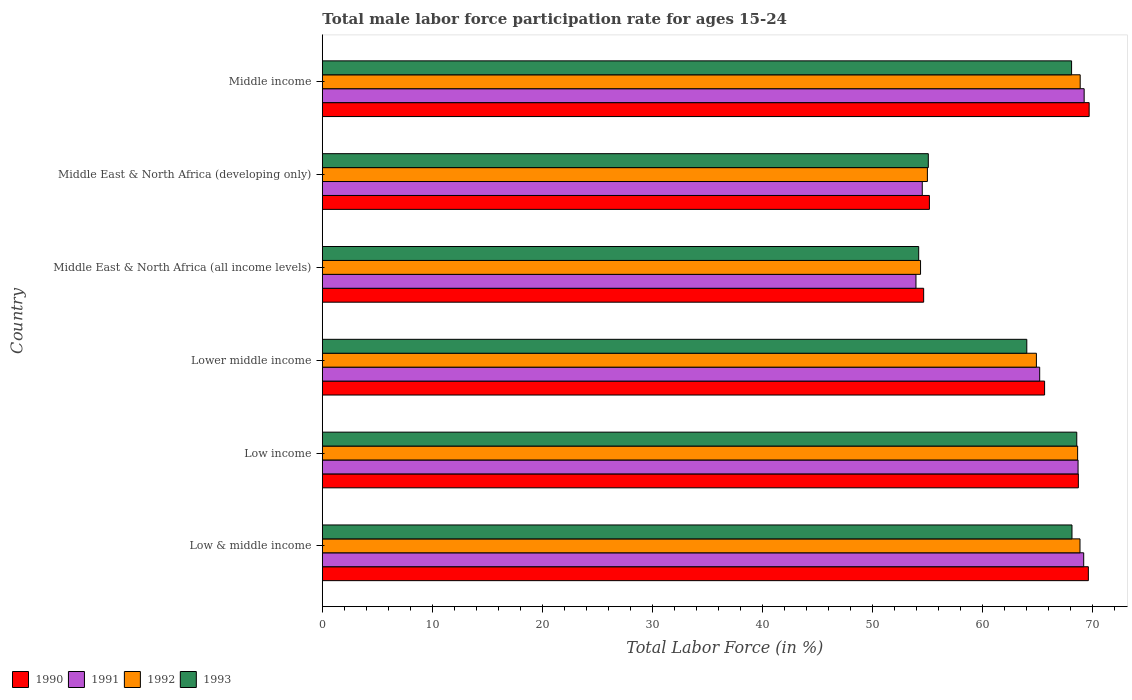How many different coloured bars are there?
Your response must be concise. 4. How many groups of bars are there?
Give a very brief answer. 6. Are the number of bars on each tick of the Y-axis equal?
Make the answer very short. Yes. How many bars are there on the 4th tick from the top?
Make the answer very short. 4. How many bars are there on the 3rd tick from the bottom?
Keep it short and to the point. 4. What is the label of the 4th group of bars from the top?
Give a very brief answer. Lower middle income. In how many cases, is the number of bars for a given country not equal to the number of legend labels?
Keep it short and to the point. 0. What is the male labor force participation rate in 1993 in Middle East & North Africa (all income levels)?
Give a very brief answer. 54.18. Across all countries, what is the maximum male labor force participation rate in 1990?
Offer a terse response. 69.67. Across all countries, what is the minimum male labor force participation rate in 1990?
Your answer should be compact. 54.63. In which country was the male labor force participation rate in 1993 maximum?
Make the answer very short. Low income. In which country was the male labor force participation rate in 1992 minimum?
Ensure brevity in your answer.  Middle East & North Africa (all income levels). What is the total male labor force participation rate in 1991 in the graph?
Keep it short and to the point. 380.65. What is the difference between the male labor force participation rate in 1990 in Low & middle income and that in Middle East & North Africa (developing only)?
Your answer should be very brief. 14.44. What is the difference between the male labor force participation rate in 1993 in Lower middle income and the male labor force participation rate in 1992 in Middle East & North Africa (all income levels)?
Provide a succinct answer. 9.65. What is the average male labor force participation rate in 1990 per country?
Offer a very short reply. 63.89. What is the difference between the male labor force participation rate in 1990 and male labor force participation rate in 1992 in Middle East & North Africa (all income levels)?
Make the answer very short. 0.28. In how many countries, is the male labor force participation rate in 1990 greater than 8 %?
Offer a very short reply. 6. What is the ratio of the male labor force participation rate in 1990 in Middle East & North Africa (developing only) to that in Middle income?
Your response must be concise. 0.79. Is the male labor force participation rate in 1990 in Low & middle income less than that in Middle East & North Africa (all income levels)?
Offer a very short reply. No. Is the difference between the male labor force participation rate in 1990 in Low income and Middle East & North Africa (developing only) greater than the difference between the male labor force participation rate in 1992 in Low income and Middle East & North Africa (developing only)?
Your answer should be compact. No. What is the difference between the highest and the second highest male labor force participation rate in 1990?
Keep it short and to the point. 0.07. What is the difference between the highest and the lowest male labor force participation rate in 1990?
Your answer should be very brief. 15.03. In how many countries, is the male labor force participation rate in 1993 greater than the average male labor force participation rate in 1993 taken over all countries?
Provide a succinct answer. 4. Is the sum of the male labor force participation rate in 1991 in Lower middle income and Middle East & North Africa (developing only) greater than the maximum male labor force participation rate in 1992 across all countries?
Offer a very short reply. Yes. Is it the case that in every country, the sum of the male labor force participation rate in 1993 and male labor force participation rate in 1990 is greater than the sum of male labor force participation rate in 1991 and male labor force participation rate in 1992?
Ensure brevity in your answer.  No. What does the 1st bar from the top in Low & middle income represents?
Ensure brevity in your answer.  1993. What is the difference between two consecutive major ticks on the X-axis?
Ensure brevity in your answer.  10. Where does the legend appear in the graph?
Your answer should be compact. Bottom left. How are the legend labels stacked?
Offer a terse response. Horizontal. What is the title of the graph?
Give a very brief answer. Total male labor force participation rate for ages 15-24. What is the label or title of the Y-axis?
Your answer should be very brief. Country. What is the Total Labor Force (in %) in 1990 in Low & middle income?
Give a very brief answer. 69.59. What is the Total Labor Force (in %) of 1991 in Low & middle income?
Ensure brevity in your answer.  69.17. What is the Total Labor Force (in %) in 1992 in Low & middle income?
Your answer should be very brief. 68.83. What is the Total Labor Force (in %) in 1993 in Low & middle income?
Offer a terse response. 68.11. What is the Total Labor Force (in %) of 1990 in Low income?
Provide a short and direct response. 68.69. What is the Total Labor Force (in %) of 1991 in Low income?
Your answer should be compact. 68.66. What is the Total Labor Force (in %) of 1992 in Low income?
Give a very brief answer. 68.62. What is the Total Labor Force (in %) of 1993 in Low income?
Ensure brevity in your answer.  68.54. What is the Total Labor Force (in %) of 1990 in Lower middle income?
Your answer should be very brief. 65.62. What is the Total Labor Force (in %) of 1991 in Lower middle income?
Your answer should be very brief. 65.17. What is the Total Labor Force (in %) in 1992 in Lower middle income?
Your answer should be very brief. 64.87. What is the Total Labor Force (in %) in 1993 in Lower middle income?
Keep it short and to the point. 64. What is the Total Labor Force (in %) in 1990 in Middle East & North Africa (all income levels)?
Offer a terse response. 54.63. What is the Total Labor Force (in %) in 1991 in Middle East & North Africa (all income levels)?
Provide a short and direct response. 53.93. What is the Total Labor Force (in %) of 1992 in Middle East & North Africa (all income levels)?
Ensure brevity in your answer.  54.35. What is the Total Labor Force (in %) in 1993 in Middle East & North Africa (all income levels)?
Your response must be concise. 54.18. What is the Total Labor Force (in %) in 1990 in Middle East & North Africa (developing only)?
Your response must be concise. 55.15. What is the Total Labor Force (in %) of 1991 in Middle East & North Africa (developing only)?
Your response must be concise. 54.5. What is the Total Labor Force (in %) in 1992 in Middle East & North Africa (developing only)?
Ensure brevity in your answer.  54.97. What is the Total Labor Force (in %) of 1993 in Middle East & North Africa (developing only)?
Provide a succinct answer. 55.05. What is the Total Labor Force (in %) in 1990 in Middle income?
Offer a terse response. 69.67. What is the Total Labor Force (in %) in 1991 in Middle income?
Keep it short and to the point. 69.21. What is the Total Labor Force (in %) of 1992 in Middle income?
Give a very brief answer. 68.85. What is the Total Labor Force (in %) of 1993 in Middle income?
Your response must be concise. 68.07. Across all countries, what is the maximum Total Labor Force (in %) in 1990?
Your answer should be very brief. 69.67. Across all countries, what is the maximum Total Labor Force (in %) of 1991?
Offer a terse response. 69.21. Across all countries, what is the maximum Total Labor Force (in %) of 1992?
Your answer should be compact. 68.85. Across all countries, what is the maximum Total Labor Force (in %) of 1993?
Your answer should be compact. 68.54. Across all countries, what is the minimum Total Labor Force (in %) of 1990?
Your response must be concise. 54.63. Across all countries, what is the minimum Total Labor Force (in %) in 1991?
Provide a succinct answer. 53.93. Across all countries, what is the minimum Total Labor Force (in %) in 1992?
Provide a succinct answer. 54.35. Across all countries, what is the minimum Total Labor Force (in %) of 1993?
Make the answer very short. 54.18. What is the total Total Labor Force (in %) in 1990 in the graph?
Your response must be concise. 383.35. What is the total Total Labor Force (in %) in 1991 in the graph?
Your answer should be compact. 380.65. What is the total Total Labor Force (in %) in 1992 in the graph?
Ensure brevity in your answer.  380.5. What is the total Total Labor Force (in %) in 1993 in the graph?
Your answer should be compact. 377.95. What is the difference between the Total Labor Force (in %) in 1990 in Low & middle income and that in Low income?
Offer a very short reply. 0.91. What is the difference between the Total Labor Force (in %) of 1991 in Low & middle income and that in Low income?
Provide a succinct answer. 0.51. What is the difference between the Total Labor Force (in %) in 1992 in Low & middle income and that in Low income?
Your response must be concise. 0.22. What is the difference between the Total Labor Force (in %) in 1993 in Low & middle income and that in Low income?
Offer a very short reply. -0.43. What is the difference between the Total Labor Force (in %) of 1990 in Low & middle income and that in Lower middle income?
Offer a very short reply. 3.98. What is the difference between the Total Labor Force (in %) of 1991 in Low & middle income and that in Lower middle income?
Ensure brevity in your answer.  4. What is the difference between the Total Labor Force (in %) of 1992 in Low & middle income and that in Lower middle income?
Ensure brevity in your answer.  3.96. What is the difference between the Total Labor Force (in %) in 1993 in Low & middle income and that in Lower middle income?
Give a very brief answer. 4.11. What is the difference between the Total Labor Force (in %) in 1990 in Low & middle income and that in Middle East & North Africa (all income levels)?
Offer a terse response. 14.96. What is the difference between the Total Labor Force (in %) of 1991 in Low & middle income and that in Middle East & North Africa (all income levels)?
Provide a succinct answer. 15.24. What is the difference between the Total Labor Force (in %) in 1992 in Low & middle income and that in Middle East & North Africa (all income levels)?
Ensure brevity in your answer.  14.49. What is the difference between the Total Labor Force (in %) of 1993 in Low & middle income and that in Middle East & North Africa (all income levels)?
Give a very brief answer. 13.93. What is the difference between the Total Labor Force (in %) of 1990 in Low & middle income and that in Middle East & North Africa (developing only)?
Your answer should be compact. 14.44. What is the difference between the Total Labor Force (in %) of 1991 in Low & middle income and that in Middle East & North Africa (developing only)?
Provide a short and direct response. 14.67. What is the difference between the Total Labor Force (in %) of 1992 in Low & middle income and that in Middle East & North Africa (developing only)?
Offer a terse response. 13.86. What is the difference between the Total Labor Force (in %) in 1993 in Low & middle income and that in Middle East & North Africa (developing only)?
Your response must be concise. 13.05. What is the difference between the Total Labor Force (in %) in 1990 in Low & middle income and that in Middle income?
Offer a very short reply. -0.07. What is the difference between the Total Labor Force (in %) of 1991 in Low & middle income and that in Middle income?
Offer a terse response. -0.04. What is the difference between the Total Labor Force (in %) of 1992 in Low & middle income and that in Middle income?
Give a very brief answer. -0.02. What is the difference between the Total Labor Force (in %) of 1993 in Low & middle income and that in Middle income?
Provide a succinct answer. 0.04. What is the difference between the Total Labor Force (in %) of 1990 in Low income and that in Lower middle income?
Your answer should be very brief. 3.07. What is the difference between the Total Labor Force (in %) in 1991 in Low income and that in Lower middle income?
Make the answer very short. 3.49. What is the difference between the Total Labor Force (in %) of 1992 in Low income and that in Lower middle income?
Provide a short and direct response. 3.74. What is the difference between the Total Labor Force (in %) in 1993 in Low income and that in Lower middle income?
Your response must be concise. 4.54. What is the difference between the Total Labor Force (in %) of 1990 in Low income and that in Middle East & North Africa (all income levels)?
Offer a terse response. 14.05. What is the difference between the Total Labor Force (in %) in 1991 in Low income and that in Middle East & North Africa (all income levels)?
Keep it short and to the point. 14.73. What is the difference between the Total Labor Force (in %) in 1992 in Low income and that in Middle East & North Africa (all income levels)?
Your answer should be very brief. 14.27. What is the difference between the Total Labor Force (in %) in 1993 in Low income and that in Middle East & North Africa (all income levels)?
Provide a succinct answer. 14.36. What is the difference between the Total Labor Force (in %) of 1990 in Low income and that in Middle East & North Africa (developing only)?
Offer a terse response. 13.53. What is the difference between the Total Labor Force (in %) in 1991 in Low income and that in Middle East & North Africa (developing only)?
Keep it short and to the point. 14.15. What is the difference between the Total Labor Force (in %) in 1992 in Low income and that in Middle East & North Africa (developing only)?
Offer a very short reply. 13.65. What is the difference between the Total Labor Force (in %) in 1993 in Low income and that in Middle East & North Africa (developing only)?
Your answer should be very brief. 13.49. What is the difference between the Total Labor Force (in %) in 1990 in Low income and that in Middle income?
Ensure brevity in your answer.  -0.98. What is the difference between the Total Labor Force (in %) in 1991 in Low income and that in Middle income?
Provide a succinct answer. -0.55. What is the difference between the Total Labor Force (in %) in 1992 in Low income and that in Middle income?
Ensure brevity in your answer.  -0.23. What is the difference between the Total Labor Force (in %) in 1993 in Low income and that in Middle income?
Keep it short and to the point. 0.47. What is the difference between the Total Labor Force (in %) in 1990 in Lower middle income and that in Middle East & North Africa (all income levels)?
Ensure brevity in your answer.  10.99. What is the difference between the Total Labor Force (in %) in 1991 in Lower middle income and that in Middle East & North Africa (all income levels)?
Your answer should be compact. 11.24. What is the difference between the Total Labor Force (in %) of 1992 in Lower middle income and that in Middle East & North Africa (all income levels)?
Provide a short and direct response. 10.53. What is the difference between the Total Labor Force (in %) of 1993 in Lower middle income and that in Middle East & North Africa (all income levels)?
Offer a terse response. 9.82. What is the difference between the Total Labor Force (in %) in 1990 in Lower middle income and that in Middle East & North Africa (developing only)?
Give a very brief answer. 10.46. What is the difference between the Total Labor Force (in %) in 1991 in Lower middle income and that in Middle East & North Africa (developing only)?
Provide a succinct answer. 10.67. What is the difference between the Total Labor Force (in %) in 1992 in Lower middle income and that in Middle East & North Africa (developing only)?
Your answer should be compact. 9.91. What is the difference between the Total Labor Force (in %) in 1993 in Lower middle income and that in Middle East & North Africa (developing only)?
Provide a succinct answer. 8.95. What is the difference between the Total Labor Force (in %) in 1990 in Lower middle income and that in Middle income?
Provide a short and direct response. -4.05. What is the difference between the Total Labor Force (in %) of 1991 in Lower middle income and that in Middle income?
Offer a terse response. -4.04. What is the difference between the Total Labor Force (in %) in 1992 in Lower middle income and that in Middle income?
Provide a short and direct response. -3.98. What is the difference between the Total Labor Force (in %) in 1993 in Lower middle income and that in Middle income?
Provide a short and direct response. -4.07. What is the difference between the Total Labor Force (in %) of 1990 in Middle East & North Africa (all income levels) and that in Middle East & North Africa (developing only)?
Keep it short and to the point. -0.52. What is the difference between the Total Labor Force (in %) of 1991 in Middle East & North Africa (all income levels) and that in Middle East & North Africa (developing only)?
Ensure brevity in your answer.  -0.57. What is the difference between the Total Labor Force (in %) in 1992 in Middle East & North Africa (all income levels) and that in Middle East & North Africa (developing only)?
Offer a terse response. -0.62. What is the difference between the Total Labor Force (in %) of 1993 in Middle East & North Africa (all income levels) and that in Middle East & North Africa (developing only)?
Provide a short and direct response. -0.88. What is the difference between the Total Labor Force (in %) of 1990 in Middle East & North Africa (all income levels) and that in Middle income?
Provide a succinct answer. -15.03. What is the difference between the Total Labor Force (in %) in 1991 in Middle East & North Africa (all income levels) and that in Middle income?
Your response must be concise. -15.28. What is the difference between the Total Labor Force (in %) in 1992 in Middle East & North Africa (all income levels) and that in Middle income?
Your response must be concise. -14.5. What is the difference between the Total Labor Force (in %) of 1993 in Middle East & North Africa (all income levels) and that in Middle income?
Your answer should be very brief. -13.89. What is the difference between the Total Labor Force (in %) in 1990 in Middle East & North Africa (developing only) and that in Middle income?
Offer a terse response. -14.51. What is the difference between the Total Labor Force (in %) of 1991 in Middle East & North Africa (developing only) and that in Middle income?
Ensure brevity in your answer.  -14.71. What is the difference between the Total Labor Force (in %) in 1992 in Middle East & North Africa (developing only) and that in Middle income?
Keep it short and to the point. -13.88. What is the difference between the Total Labor Force (in %) in 1993 in Middle East & North Africa (developing only) and that in Middle income?
Your answer should be compact. -13.02. What is the difference between the Total Labor Force (in %) in 1990 in Low & middle income and the Total Labor Force (in %) in 1991 in Low income?
Ensure brevity in your answer.  0.94. What is the difference between the Total Labor Force (in %) in 1990 in Low & middle income and the Total Labor Force (in %) in 1992 in Low income?
Provide a succinct answer. 0.98. What is the difference between the Total Labor Force (in %) of 1990 in Low & middle income and the Total Labor Force (in %) of 1993 in Low income?
Make the answer very short. 1.05. What is the difference between the Total Labor Force (in %) in 1991 in Low & middle income and the Total Labor Force (in %) in 1992 in Low income?
Provide a short and direct response. 0.55. What is the difference between the Total Labor Force (in %) in 1991 in Low & middle income and the Total Labor Force (in %) in 1993 in Low income?
Offer a very short reply. 0.63. What is the difference between the Total Labor Force (in %) of 1992 in Low & middle income and the Total Labor Force (in %) of 1993 in Low income?
Give a very brief answer. 0.29. What is the difference between the Total Labor Force (in %) in 1990 in Low & middle income and the Total Labor Force (in %) in 1991 in Lower middle income?
Keep it short and to the point. 4.42. What is the difference between the Total Labor Force (in %) in 1990 in Low & middle income and the Total Labor Force (in %) in 1992 in Lower middle income?
Provide a succinct answer. 4.72. What is the difference between the Total Labor Force (in %) in 1990 in Low & middle income and the Total Labor Force (in %) in 1993 in Lower middle income?
Ensure brevity in your answer.  5.59. What is the difference between the Total Labor Force (in %) of 1991 in Low & middle income and the Total Labor Force (in %) of 1992 in Lower middle income?
Ensure brevity in your answer.  4.3. What is the difference between the Total Labor Force (in %) in 1991 in Low & middle income and the Total Labor Force (in %) in 1993 in Lower middle income?
Keep it short and to the point. 5.17. What is the difference between the Total Labor Force (in %) of 1992 in Low & middle income and the Total Labor Force (in %) of 1993 in Lower middle income?
Offer a very short reply. 4.83. What is the difference between the Total Labor Force (in %) of 1990 in Low & middle income and the Total Labor Force (in %) of 1991 in Middle East & North Africa (all income levels)?
Your response must be concise. 15.66. What is the difference between the Total Labor Force (in %) in 1990 in Low & middle income and the Total Labor Force (in %) in 1992 in Middle East & North Africa (all income levels)?
Your response must be concise. 15.25. What is the difference between the Total Labor Force (in %) of 1990 in Low & middle income and the Total Labor Force (in %) of 1993 in Middle East & North Africa (all income levels)?
Your answer should be compact. 15.42. What is the difference between the Total Labor Force (in %) of 1991 in Low & middle income and the Total Labor Force (in %) of 1992 in Middle East & North Africa (all income levels)?
Give a very brief answer. 14.82. What is the difference between the Total Labor Force (in %) in 1991 in Low & middle income and the Total Labor Force (in %) in 1993 in Middle East & North Africa (all income levels)?
Offer a very short reply. 14.99. What is the difference between the Total Labor Force (in %) in 1992 in Low & middle income and the Total Labor Force (in %) in 1993 in Middle East & North Africa (all income levels)?
Keep it short and to the point. 14.66. What is the difference between the Total Labor Force (in %) in 1990 in Low & middle income and the Total Labor Force (in %) in 1991 in Middle East & North Africa (developing only)?
Keep it short and to the point. 15.09. What is the difference between the Total Labor Force (in %) of 1990 in Low & middle income and the Total Labor Force (in %) of 1992 in Middle East & North Africa (developing only)?
Your answer should be compact. 14.62. What is the difference between the Total Labor Force (in %) of 1990 in Low & middle income and the Total Labor Force (in %) of 1993 in Middle East & North Africa (developing only)?
Give a very brief answer. 14.54. What is the difference between the Total Labor Force (in %) in 1991 in Low & middle income and the Total Labor Force (in %) in 1992 in Middle East & North Africa (developing only)?
Make the answer very short. 14.2. What is the difference between the Total Labor Force (in %) of 1991 in Low & middle income and the Total Labor Force (in %) of 1993 in Middle East & North Africa (developing only)?
Your answer should be very brief. 14.12. What is the difference between the Total Labor Force (in %) of 1992 in Low & middle income and the Total Labor Force (in %) of 1993 in Middle East & North Africa (developing only)?
Your answer should be very brief. 13.78. What is the difference between the Total Labor Force (in %) in 1990 in Low & middle income and the Total Labor Force (in %) in 1991 in Middle income?
Keep it short and to the point. 0.38. What is the difference between the Total Labor Force (in %) of 1990 in Low & middle income and the Total Labor Force (in %) of 1992 in Middle income?
Keep it short and to the point. 0.74. What is the difference between the Total Labor Force (in %) of 1990 in Low & middle income and the Total Labor Force (in %) of 1993 in Middle income?
Your answer should be compact. 1.52. What is the difference between the Total Labor Force (in %) of 1991 in Low & middle income and the Total Labor Force (in %) of 1992 in Middle income?
Offer a terse response. 0.32. What is the difference between the Total Labor Force (in %) in 1991 in Low & middle income and the Total Labor Force (in %) in 1993 in Middle income?
Your answer should be compact. 1.1. What is the difference between the Total Labor Force (in %) of 1992 in Low & middle income and the Total Labor Force (in %) of 1993 in Middle income?
Make the answer very short. 0.76. What is the difference between the Total Labor Force (in %) in 1990 in Low income and the Total Labor Force (in %) in 1991 in Lower middle income?
Your answer should be compact. 3.51. What is the difference between the Total Labor Force (in %) of 1990 in Low income and the Total Labor Force (in %) of 1992 in Lower middle income?
Offer a terse response. 3.81. What is the difference between the Total Labor Force (in %) of 1990 in Low income and the Total Labor Force (in %) of 1993 in Lower middle income?
Your answer should be very brief. 4.68. What is the difference between the Total Labor Force (in %) in 1991 in Low income and the Total Labor Force (in %) in 1992 in Lower middle income?
Your answer should be very brief. 3.78. What is the difference between the Total Labor Force (in %) in 1991 in Low income and the Total Labor Force (in %) in 1993 in Lower middle income?
Ensure brevity in your answer.  4.66. What is the difference between the Total Labor Force (in %) in 1992 in Low income and the Total Labor Force (in %) in 1993 in Lower middle income?
Provide a short and direct response. 4.62. What is the difference between the Total Labor Force (in %) in 1990 in Low income and the Total Labor Force (in %) in 1991 in Middle East & North Africa (all income levels)?
Provide a short and direct response. 14.75. What is the difference between the Total Labor Force (in %) in 1990 in Low income and the Total Labor Force (in %) in 1992 in Middle East & North Africa (all income levels)?
Offer a very short reply. 14.34. What is the difference between the Total Labor Force (in %) of 1990 in Low income and the Total Labor Force (in %) of 1993 in Middle East & North Africa (all income levels)?
Your answer should be very brief. 14.51. What is the difference between the Total Labor Force (in %) in 1991 in Low income and the Total Labor Force (in %) in 1992 in Middle East & North Africa (all income levels)?
Give a very brief answer. 14.31. What is the difference between the Total Labor Force (in %) of 1991 in Low income and the Total Labor Force (in %) of 1993 in Middle East & North Africa (all income levels)?
Provide a short and direct response. 14.48. What is the difference between the Total Labor Force (in %) in 1992 in Low income and the Total Labor Force (in %) in 1993 in Middle East & North Africa (all income levels)?
Provide a succinct answer. 14.44. What is the difference between the Total Labor Force (in %) in 1990 in Low income and the Total Labor Force (in %) in 1991 in Middle East & North Africa (developing only)?
Your answer should be compact. 14.18. What is the difference between the Total Labor Force (in %) of 1990 in Low income and the Total Labor Force (in %) of 1992 in Middle East & North Africa (developing only)?
Offer a terse response. 13.72. What is the difference between the Total Labor Force (in %) in 1990 in Low income and the Total Labor Force (in %) in 1993 in Middle East & North Africa (developing only)?
Make the answer very short. 13.63. What is the difference between the Total Labor Force (in %) in 1991 in Low income and the Total Labor Force (in %) in 1992 in Middle East & North Africa (developing only)?
Provide a short and direct response. 13.69. What is the difference between the Total Labor Force (in %) of 1991 in Low income and the Total Labor Force (in %) of 1993 in Middle East & North Africa (developing only)?
Provide a short and direct response. 13.6. What is the difference between the Total Labor Force (in %) of 1992 in Low income and the Total Labor Force (in %) of 1993 in Middle East & North Africa (developing only)?
Your answer should be compact. 13.56. What is the difference between the Total Labor Force (in %) of 1990 in Low income and the Total Labor Force (in %) of 1991 in Middle income?
Your answer should be compact. -0.53. What is the difference between the Total Labor Force (in %) in 1990 in Low income and the Total Labor Force (in %) in 1992 in Middle income?
Ensure brevity in your answer.  -0.17. What is the difference between the Total Labor Force (in %) in 1990 in Low income and the Total Labor Force (in %) in 1993 in Middle income?
Provide a succinct answer. 0.62. What is the difference between the Total Labor Force (in %) of 1991 in Low income and the Total Labor Force (in %) of 1992 in Middle income?
Make the answer very short. -0.19. What is the difference between the Total Labor Force (in %) of 1991 in Low income and the Total Labor Force (in %) of 1993 in Middle income?
Offer a terse response. 0.59. What is the difference between the Total Labor Force (in %) in 1992 in Low income and the Total Labor Force (in %) in 1993 in Middle income?
Give a very brief answer. 0.55. What is the difference between the Total Labor Force (in %) of 1990 in Lower middle income and the Total Labor Force (in %) of 1991 in Middle East & North Africa (all income levels)?
Keep it short and to the point. 11.68. What is the difference between the Total Labor Force (in %) of 1990 in Lower middle income and the Total Labor Force (in %) of 1992 in Middle East & North Africa (all income levels)?
Your response must be concise. 11.27. What is the difference between the Total Labor Force (in %) of 1990 in Lower middle income and the Total Labor Force (in %) of 1993 in Middle East & North Africa (all income levels)?
Provide a short and direct response. 11.44. What is the difference between the Total Labor Force (in %) in 1991 in Lower middle income and the Total Labor Force (in %) in 1992 in Middle East & North Africa (all income levels)?
Keep it short and to the point. 10.82. What is the difference between the Total Labor Force (in %) in 1991 in Lower middle income and the Total Labor Force (in %) in 1993 in Middle East & North Africa (all income levels)?
Your answer should be very brief. 10.99. What is the difference between the Total Labor Force (in %) of 1992 in Lower middle income and the Total Labor Force (in %) of 1993 in Middle East & North Africa (all income levels)?
Offer a terse response. 10.7. What is the difference between the Total Labor Force (in %) of 1990 in Lower middle income and the Total Labor Force (in %) of 1991 in Middle East & North Africa (developing only)?
Make the answer very short. 11.11. What is the difference between the Total Labor Force (in %) of 1990 in Lower middle income and the Total Labor Force (in %) of 1992 in Middle East & North Africa (developing only)?
Your response must be concise. 10.65. What is the difference between the Total Labor Force (in %) in 1990 in Lower middle income and the Total Labor Force (in %) in 1993 in Middle East & North Africa (developing only)?
Keep it short and to the point. 10.56. What is the difference between the Total Labor Force (in %) of 1991 in Lower middle income and the Total Labor Force (in %) of 1992 in Middle East & North Africa (developing only)?
Give a very brief answer. 10.2. What is the difference between the Total Labor Force (in %) in 1991 in Lower middle income and the Total Labor Force (in %) in 1993 in Middle East & North Africa (developing only)?
Your answer should be very brief. 10.12. What is the difference between the Total Labor Force (in %) of 1992 in Lower middle income and the Total Labor Force (in %) of 1993 in Middle East & North Africa (developing only)?
Provide a succinct answer. 9.82. What is the difference between the Total Labor Force (in %) of 1990 in Lower middle income and the Total Labor Force (in %) of 1991 in Middle income?
Provide a succinct answer. -3.59. What is the difference between the Total Labor Force (in %) of 1990 in Lower middle income and the Total Labor Force (in %) of 1992 in Middle income?
Give a very brief answer. -3.23. What is the difference between the Total Labor Force (in %) of 1990 in Lower middle income and the Total Labor Force (in %) of 1993 in Middle income?
Ensure brevity in your answer.  -2.45. What is the difference between the Total Labor Force (in %) of 1991 in Lower middle income and the Total Labor Force (in %) of 1992 in Middle income?
Ensure brevity in your answer.  -3.68. What is the difference between the Total Labor Force (in %) in 1991 in Lower middle income and the Total Labor Force (in %) in 1993 in Middle income?
Offer a terse response. -2.9. What is the difference between the Total Labor Force (in %) in 1992 in Lower middle income and the Total Labor Force (in %) in 1993 in Middle income?
Provide a short and direct response. -3.2. What is the difference between the Total Labor Force (in %) in 1990 in Middle East & North Africa (all income levels) and the Total Labor Force (in %) in 1991 in Middle East & North Africa (developing only)?
Provide a succinct answer. 0.13. What is the difference between the Total Labor Force (in %) of 1990 in Middle East & North Africa (all income levels) and the Total Labor Force (in %) of 1992 in Middle East & North Africa (developing only)?
Your response must be concise. -0.34. What is the difference between the Total Labor Force (in %) of 1990 in Middle East & North Africa (all income levels) and the Total Labor Force (in %) of 1993 in Middle East & North Africa (developing only)?
Your response must be concise. -0.42. What is the difference between the Total Labor Force (in %) of 1991 in Middle East & North Africa (all income levels) and the Total Labor Force (in %) of 1992 in Middle East & North Africa (developing only)?
Provide a short and direct response. -1.04. What is the difference between the Total Labor Force (in %) of 1991 in Middle East & North Africa (all income levels) and the Total Labor Force (in %) of 1993 in Middle East & North Africa (developing only)?
Give a very brief answer. -1.12. What is the difference between the Total Labor Force (in %) in 1992 in Middle East & North Africa (all income levels) and the Total Labor Force (in %) in 1993 in Middle East & North Africa (developing only)?
Ensure brevity in your answer.  -0.7. What is the difference between the Total Labor Force (in %) of 1990 in Middle East & North Africa (all income levels) and the Total Labor Force (in %) of 1991 in Middle income?
Make the answer very short. -14.58. What is the difference between the Total Labor Force (in %) of 1990 in Middle East & North Africa (all income levels) and the Total Labor Force (in %) of 1992 in Middle income?
Offer a terse response. -14.22. What is the difference between the Total Labor Force (in %) in 1990 in Middle East & North Africa (all income levels) and the Total Labor Force (in %) in 1993 in Middle income?
Provide a succinct answer. -13.44. What is the difference between the Total Labor Force (in %) in 1991 in Middle East & North Africa (all income levels) and the Total Labor Force (in %) in 1992 in Middle income?
Ensure brevity in your answer.  -14.92. What is the difference between the Total Labor Force (in %) of 1991 in Middle East & North Africa (all income levels) and the Total Labor Force (in %) of 1993 in Middle income?
Make the answer very short. -14.14. What is the difference between the Total Labor Force (in %) of 1992 in Middle East & North Africa (all income levels) and the Total Labor Force (in %) of 1993 in Middle income?
Ensure brevity in your answer.  -13.72. What is the difference between the Total Labor Force (in %) of 1990 in Middle East & North Africa (developing only) and the Total Labor Force (in %) of 1991 in Middle income?
Your answer should be compact. -14.06. What is the difference between the Total Labor Force (in %) of 1990 in Middle East & North Africa (developing only) and the Total Labor Force (in %) of 1992 in Middle income?
Offer a very short reply. -13.7. What is the difference between the Total Labor Force (in %) in 1990 in Middle East & North Africa (developing only) and the Total Labor Force (in %) in 1993 in Middle income?
Make the answer very short. -12.92. What is the difference between the Total Labor Force (in %) in 1991 in Middle East & North Africa (developing only) and the Total Labor Force (in %) in 1992 in Middle income?
Your answer should be very brief. -14.35. What is the difference between the Total Labor Force (in %) in 1991 in Middle East & North Africa (developing only) and the Total Labor Force (in %) in 1993 in Middle income?
Your answer should be compact. -13.57. What is the difference between the Total Labor Force (in %) in 1992 in Middle East & North Africa (developing only) and the Total Labor Force (in %) in 1993 in Middle income?
Provide a short and direct response. -13.1. What is the average Total Labor Force (in %) in 1990 per country?
Keep it short and to the point. 63.89. What is the average Total Labor Force (in %) of 1991 per country?
Make the answer very short. 63.44. What is the average Total Labor Force (in %) of 1992 per country?
Provide a succinct answer. 63.42. What is the average Total Labor Force (in %) in 1993 per country?
Give a very brief answer. 62.99. What is the difference between the Total Labor Force (in %) of 1990 and Total Labor Force (in %) of 1991 in Low & middle income?
Offer a very short reply. 0.42. What is the difference between the Total Labor Force (in %) of 1990 and Total Labor Force (in %) of 1992 in Low & middle income?
Your response must be concise. 0.76. What is the difference between the Total Labor Force (in %) in 1990 and Total Labor Force (in %) in 1993 in Low & middle income?
Your answer should be compact. 1.49. What is the difference between the Total Labor Force (in %) of 1991 and Total Labor Force (in %) of 1992 in Low & middle income?
Keep it short and to the point. 0.34. What is the difference between the Total Labor Force (in %) of 1991 and Total Labor Force (in %) of 1993 in Low & middle income?
Ensure brevity in your answer.  1.06. What is the difference between the Total Labor Force (in %) of 1992 and Total Labor Force (in %) of 1993 in Low & middle income?
Your response must be concise. 0.73. What is the difference between the Total Labor Force (in %) of 1990 and Total Labor Force (in %) of 1991 in Low income?
Give a very brief answer. 0.03. What is the difference between the Total Labor Force (in %) of 1990 and Total Labor Force (in %) of 1992 in Low income?
Offer a terse response. 0.07. What is the difference between the Total Labor Force (in %) of 1990 and Total Labor Force (in %) of 1993 in Low income?
Your answer should be compact. 0.14. What is the difference between the Total Labor Force (in %) of 1991 and Total Labor Force (in %) of 1992 in Low income?
Make the answer very short. 0.04. What is the difference between the Total Labor Force (in %) of 1991 and Total Labor Force (in %) of 1993 in Low income?
Offer a very short reply. 0.12. What is the difference between the Total Labor Force (in %) in 1992 and Total Labor Force (in %) in 1993 in Low income?
Offer a very short reply. 0.08. What is the difference between the Total Labor Force (in %) in 1990 and Total Labor Force (in %) in 1991 in Lower middle income?
Your response must be concise. 0.45. What is the difference between the Total Labor Force (in %) in 1990 and Total Labor Force (in %) in 1992 in Lower middle income?
Your response must be concise. 0.74. What is the difference between the Total Labor Force (in %) of 1990 and Total Labor Force (in %) of 1993 in Lower middle income?
Your response must be concise. 1.62. What is the difference between the Total Labor Force (in %) in 1991 and Total Labor Force (in %) in 1992 in Lower middle income?
Provide a short and direct response. 0.3. What is the difference between the Total Labor Force (in %) in 1991 and Total Labor Force (in %) in 1993 in Lower middle income?
Offer a very short reply. 1.17. What is the difference between the Total Labor Force (in %) in 1992 and Total Labor Force (in %) in 1993 in Lower middle income?
Provide a succinct answer. 0.87. What is the difference between the Total Labor Force (in %) of 1990 and Total Labor Force (in %) of 1991 in Middle East & North Africa (all income levels)?
Provide a succinct answer. 0.7. What is the difference between the Total Labor Force (in %) of 1990 and Total Labor Force (in %) of 1992 in Middle East & North Africa (all income levels)?
Your answer should be compact. 0.28. What is the difference between the Total Labor Force (in %) in 1990 and Total Labor Force (in %) in 1993 in Middle East & North Africa (all income levels)?
Your answer should be compact. 0.45. What is the difference between the Total Labor Force (in %) of 1991 and Total Labor Force (in %) of 1992 in Middle East & North Africa (all income levels)?
Provide a succinct answer. -0.42. What is the difference between the Total Labor Force (in %) in 1991 and Total Labor Force (in %) in 1993 in Middle East & North Africa (all income levels)?
Provide a succinct answer. -0.25. What is the difference between the Total Labor Force (in %) in 1992 and Total Labor Force (in %) in 1993 in Middle East & North Africa (all income levels)?
Ensure brevity in your answer.  0.17. What is the difference between the Total Labor Force (in %) in 1990 and Total Labor Force (in %) in 1991 in Middle East & North Africa (developing only)?
Provide a succinct answer. 0.65. What is the difference between the Total Labor Force (in %) in 1990 and Total Labor Force (in %) in 1992 in Middle East & North Africa (developing only)?
Ensure brevity in your answer.  0.18. What is the difference between the Total Labor Force (in %) in 1990 and Total Labor Force (in %) in 1993 in Middle East & North Africa (developing only)?
Your response must be concise. 0.1. What is the difference between the Total Labor Force (in %) in 1991 and Total Labor Force (in %) in 1992 in Middle East & North Africa (developing only)?
Provide a succinct answer. -0.47. What is the difference between the Total Labor Force (in %) in 1991 and Total Labor Force (in %) in 1993 in Middle East & North Africa (developing only)?
Offer a terse response. -0.55. What is the difference between the Total Labor Force (in %) of 1992 and Total Labor Force (in %) of 1993 in Middle East & North Africa (developing only)?
Provide a succinct answer. -0.08. What is the difference between the Total Labor Force (in %) in 1990 and Total Labor Force (in %) in 1991 in Middle income?
Ensure brevity in your answer.  0.45. What is the difference between the Total Labor Force (in %) in 1990 and Total Labor Force (in %) in 1992 in Middle income?
Provide a short and direct response. 0.81. What is the difference between the Total Labor Force (in %) in 1990 and Total Labor Force (in %) in 1993 in Middle income?
Ensure brevity in your answer.  1.6. What is the difference between the Total Labor Force (in %) of 1991 and Total Labor Force (in %) of 1992 in Middle income?
Your answer should be very brief. 0.36. What is the difference between the Total Labor Force (in %) of 1991 and Total Labor Force (in %) of 1993 in Middle income?
Ensure brevity in your answer.  1.14. What is the difference between the Total Labor Force (in %) in 1992 and Total Labor Force (in %) in 1993 in Middle income?
Your answer should be compact. 0.78. What is the ratio of the Total Labor Force (in %) of 1990 in Low & middle income to that in Low income?
Your response must be concise. 1.01. What is the ratio of the Total Labor Force (in %) of 1991 in Low & middle income to that in Low income?
Offer a very short reply. 1.01. What is the ratio of the Total Labor Force (in %) of 1992 in Low & middle income to that in Low income?
Give a very brief answer. 1. What is the ratio of the Total Labor Force (in %) in 1990 in Low & middle income to that in Lower middle income?
Offer a very short reply. 1.06. What is the ratio of the Total Labor Force (in %) of 1991 in Low & middle income to that in Lower middle income?
Your answer should be very brief. 1.06. What is the ratio of the Total Labor Force (in %) in 1992 in Low & middle income to that in Lower middle income?
Your answer should be compact. 1.06. What is the ratio of the Total Labor Force (in %) of 1993 in Low & middle income to that in Lower middle income?
Your answer should be compact. 1.06. What is the ratio of the Total Labor Force (in %) in 1990 in Low & middle income to that in Middle East & North Africa (all income levels)?
Provide a short and direct response. 1.27. What is the ratio of the Total Labor Force (in %) of 1991 in Low & middle income to that in Middle East & North Africa (all income levels)?
Ensure brevity in your answer.  1.28. What is the ratio of the Total Labor Force (in %) in 1992 in Low & middle income to that in Middle East & North Africa (all income levels)?
Offer a terse response. 1.27. What is the ratio of the Total Labor Force (in %) of 1993 in Low & middle income to that in Middle East & North Africa (all income levels)?
Offer a very short reply. 1.26. What is the ratio of the Total Labor Force (in %) of 1990 in Low & middle income to that in Middle East & North Africa (developing only)?
Keep it short and to the point. 1.26. What is the ratio of the Total Labor Force (in %) in 1991 in Low & middle income to that in Middle East & North Africa (developing only)?
Your answer should be very brief. 1.27. What is the ratio of the Total Labor Force (in %) of 1992 in Low & middle income to that in Middle East & North Africa (developing only)?
Keep it short and to the point. 1.25. What is the ratio of the Total Labor Force (in %) in 1993 in Low & middle income to that in Middle East & North Africa (developing only)?
Offer a very short reply. 1.24. What is the ratio of the Total Labor Force (in %) of 1992 in Low & middle income to that in Middle income?
Your response must be concise. 1. What is the ratio of the Total Labor Force (in %) of 1993 in Low & middle income to that in Middle income?
Keep it short and to the point. 1. What is the ratio of the Total Labor Force (in %) of 1990 in Low income to that in Lower middle income?
Your answer should be very brief. 1.05. What is the ratio of the Total Labor Force (in %) in 1991 in Low income to that in Lower middle income?
Offer a very short reply. 1.05. What is the ratio of the Total Labor Force (in %) of 1992 in Low income to that in Lower middle income?
Your answer should be compact. 1.06. What is the ratio of the Total Labor Force (in %) of 1993 in Low income to that in Lower middle income?
Give a very brief answer. 1.07. What is the ratio of the Total Labor Force (in %) in 1990 in Low income to that in Middle East & North Africa (all income levels)?
Your response must be concise. 1.26. What is the ratio of the Total Labor Force (in %) of 1991 in Low income to that in Middle East & North Africa (all income levels)?
Provide a succinct answer. 1.27. What is the ratio of the Total Labor Force (in %) of 1992 in Low income to that in Middle East & North Africa (all income levels)?
Provide a short and direct response. 1.26. What is the ratio of the Total Labor Force (in %) of 1993 in Low income to that in Middle East & North Africa (all income levels)?
Your response must be concise. 1.27. What is the ratio of the Total Labor Force (in %) of 1990 in Low income to that in Middle East & North Africa (developing only)?
Provide a succinct answer. 1.25. What is the ratio of the Total Labor Force (in %) in 1991 in Low income to that in Middle East & North Africa (developing only)?
Your answer should be very brief. 1.26. What is the ratio of the Total Labor Force (in %) in 1992 in Low income to that in Middle East & North Africa (developing only)?
Offer a terse response. 1.25. What is the ratio of the Total Labor Force (in %) in 1993 in Low income to that in Middle East & North Africa (developing only)?
Provide a short and direct response. 1.25. What is the ratio of the Total Labor Force (in %) of 1990 in Low income to that in Middle income?
Provide a short and direct response. 0.99. What is the ratio of the Total Labor Force (in %) in 1992 in Low income to that in Middle income?
Your response must be concise. 1. What is the ratio of the Total Labor Force (in %) in 1993 in Low income to that in Middle income?
Your answer should be very brief. 1.01. What is the ratio of the Total Labor Force (in %) in 1990 in Lower middle income to that in Middle East & North Africa (all income levels)?
Give a very brief answer. 1.2. What is the ratio of the Total Labor Force (in %) in 1991 in Lower middle income to that in Middle East & North Africa (all income levels)?
Keep it short and to the point. 1.21. What is the ratio of the Total Labor Force (in %) in 1992 in Lower middle income to that in Middle East & North Africa (all income levels)?
Provide a short and direct response. 1.19. What is the ratio of the Total Labor Force (in %) of 1993 in Lower middle income to that in Middle East & North Africa (all income levels)?
Provide a short and direct response. 1.18. What is the ratio of the Total Labor Force (in %) in 1990 in Lower middle income to that in Middle East & North Africa (developing only)?
Your answer should be very brief. 1.19. What is the ratio of the Total Labor Force (in %) in 1991 in Lower middle income to that in Middle East & North Africa (developing only)?
Offer a very short reply. 1.2. What is the ratio of the Total Labor Force (in %) in 1992 in Lower middle income to that in Middle East & North Africa (developing only)?
Provide a short and direct response. 1.18. What is the ratio of the Total Labor Force (in %) of 1993 in Lower middle income to that in Middle East & North Africa (developing only)?
Make the answer very short. 1.16. What is the ratio of the Total Labor Force (in %) in 1990 in Lower middle income to that in Middle income?
Offer a very short reply. 0.94. What is the ratio of the Total Labor Force (in %) of 1991 in Lower middle income to that in Middle income?
Provide a short and direct response. 0.94. What is the ratio of the Total Labor Force (in %) in 1992 in Lower middle income to that in Middle income?
Give a very brief answer. 0.94. What is the ratio of the Total Labor Force (in %) in 1993 in Lower middle income to that in Middle income?
Your answer should be compact. 0.94. What is the ratio of the Total Labor Force (in %) of 1990 in Middle East & North Africa (all income levels) to that in Middle East & North Africa (developing only)?
Ensure brevity in your answer.  0.99. What is the ratio of the Total Labor Force (in %) in 1992 in Middle East & North Africa (all income levels) to that in Middle East & North Africa (developing only)?
Provide a short and direct response. 0.99. What is the ratio of the Total Labor Force (in %) of 1993 in Middle East & North Africa (all income levels) to that in Middle East & North Africa (developing only)?
Give a very brief answer. 0.98. What is the ratio of the Total Labor Force (in %) of 1990 in Middle East & North Africa (all income levels) to that in Middle income?
Your answer should be compact. 0.78. What is the ratio of the Total Labor Force (in %) in 1991 in Middle East & North Africa (all income levels) to that in Middle income?
Your response must be concise. 0.78. What is the ratio of the Total Labor Force (in %) of 1992 in Middle East & North Africa (all income levels) to that in Middle income?
Give a very brief answer. 0.79. What is the ratio of the Total Labor Force (in %) of 1993 in Middle East & North Africa (all income levels) to that in Middle income?
Your answer should be compact. 0.8. What is the ratio of the Total Labor Force (in %) of 1990 in Middle East & North Africa (developing only) to that in Middle income?
Provide a short and direct response. 0.79. What is the ratio of the Total Labor Force (in %) in 1991 in Middle East & North Africa (developing only) to that in Middle income?
Ensure brevity in your answer.  0.79. What is the ratio of the Total Labor Force (in %) in 1992 in Middle East & North Africa (developing only) to that in Middle income?
Provide a succinct answer. 0.8. What is the ratio of the Total Labor Force (in %) of 1993 in Middle East & North Africa (developing only) to that in Middle income?
Your answer should be very brief. 0.81. What is the difference between the highest and the second highest Total Labor Force (in %) of 1990?
Ensure brevity in your answer.  0.07. What is the difference between the highest and the second highest Total Labor Force (in %) in 1991?
Make the answer very short. 0.04. What is the difference between the highest and the second highest Total Labor Force (in %) in 1992?
Keep it short and to the point. 0.02. What is the difference between the highest and the second highest Total Labor Force (in %) of 1993?
Provide a succinct answer. 0.43. What is the difference between the highest and the lowest Total Labor Force (in %) of 1990?
Your answer should be compact. 15.03. What is the difference between the highest and the lowest Total Labor Force (in %) in 1991?
Offer a terse response. 15.28. What is the difference between the highest and the lowest Total Labor Force (in %) in 1992?
Offer a very short reply. 14.5. What is the difference between the highest and the lowest Total Labor Force (in %) in 1993?
Give a very brief answer. 14.36. 